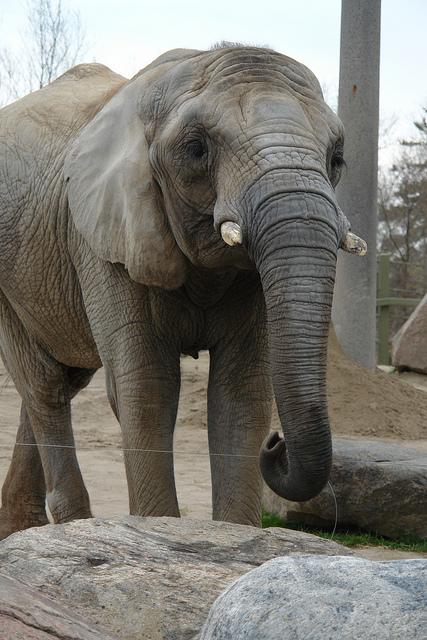Does the elephant look like it's giving a "side eye"?
Keep it brief. No. Is it a sunny day?
Write a very short answer. Yes. What color is the elephant?
Answer briefly. Gray. Where are the elephant's tusks?
Concise answer only. Gone. Is the elephant happy?
Quick response, please. Yes. Does the elephant like hot weather?
Be succinct. Yes. 